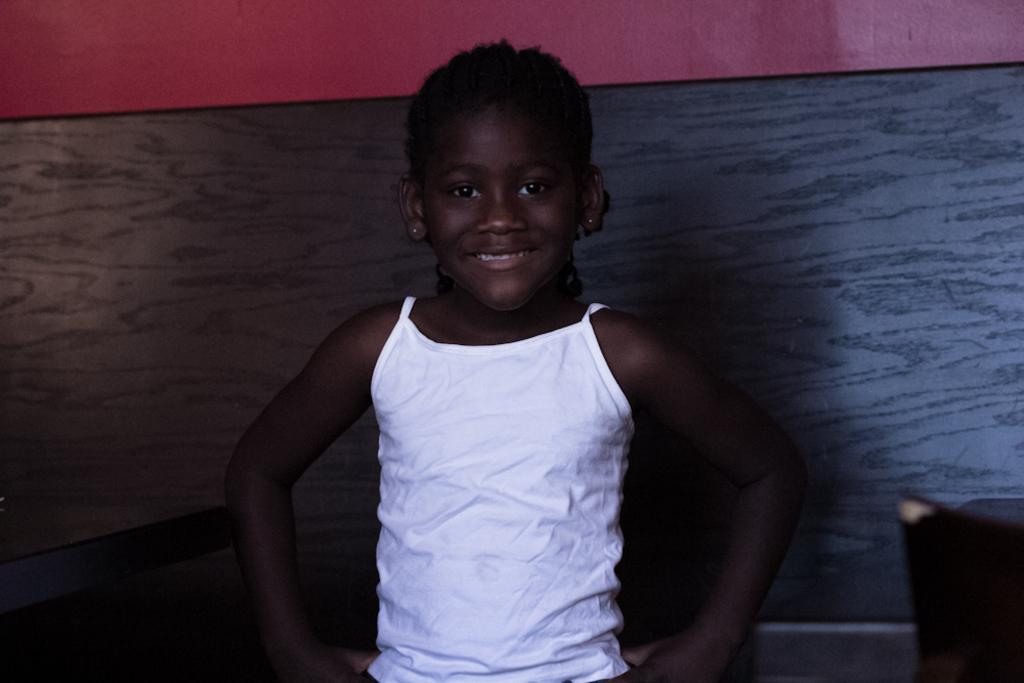Who is the main subject in the image? There is a girl in the image. What is the girl wearing? The girl is wearing a white dress. What is the girl's expression in the image? The girl is smiling. What furniture can be seen on the right side of the image? There is a chair and a table on the right side of the image. What is visible at the top of the image? There is a wall at the top of the image. What type of bell can be heard ringing in the image? There is no bell present in the image, and therefore no sound can be heard. 